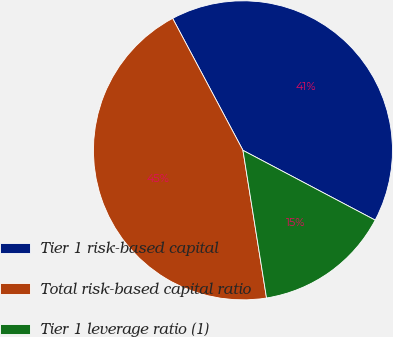Convert chart. <chart><loc_0><loc_0><loc_500><loc_500><pie_chart><fcel>Tier 1 risk-based capital<fcel>Total risk-based capital ratio<fcel>Tier 1 leverage ratio (1)<nl><fcel>40.52%<fcel>44.73%<fcel>14.75%<nl></chart> 